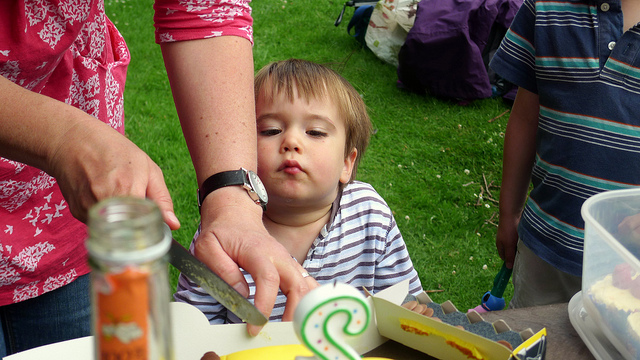How many knives can be seen? 1 